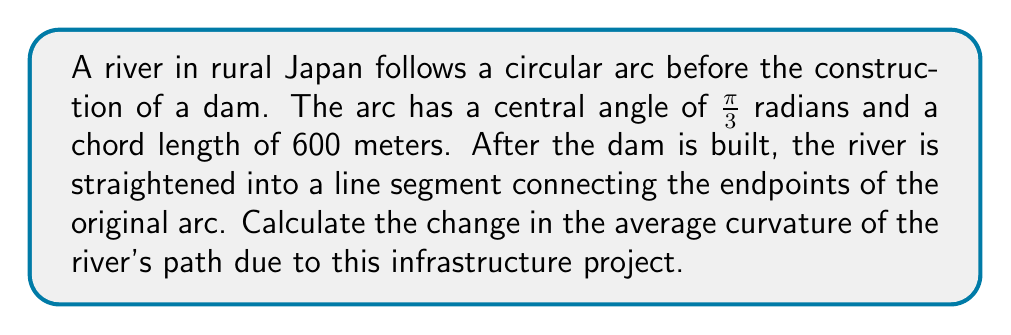Solve this math problem. 1) First, let's calculate the radius of the original circular arc:
   The chord length $c$ relates to the radius $r$ and central angle $\theta$ by:
   $c = 2r\sin(\frac{\theta}{2})$
   
   $600 = 2r\sin(\frac{\pi}{6})$
   $600 = 2r(\frac{1}{2}) = r$
   
   So, $r = 600$ meters.

2) The curvature of a circle is the reciprocal of its radius:
   $\kappa_{before} = \frac{1}{r} = \frac{1}{600} \approx 0.001667$ m$^{-1}$

3) After straightening, the river follows a straight line. A straight line has zero curvature:
   $\kappa_{after} = 0$ m$^{-1}$

4) The change in curvature is:
   $\Delta\kappa = \kappa_{after} - \kappa_{before} = 0 - \frac{1}{600} = -\frac{1}{600}$ m$^{-1}$

5) The negative value indicates a decrease in curvature, which is expected as the river is straightened.
Answer: $-\frac{1}{600}$ m$^{-1}$ 